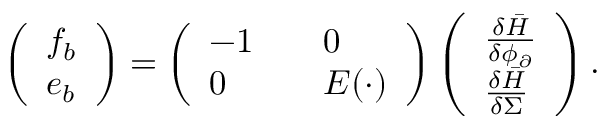<formula> <loc_0><loc_0><loc_500><loc_500>\begin{array} { r } { \left ( \begin{array} { l } { f _ { b } } \\ { e _ { b } } \end{array} \right ) = \left ( \begin{array} { l l } { - 1 \quad } & { 0 } \\ { 0 \quad } & { E ( \cdot ) } \end{array} \right ) \left ( \begin{array} { l } { \frac { \delta \bar { H } } { \delta \phi _ { \partial } } } \\ { \frac { \delta \bar { H } } { \delta \Sigma } } \end{array} \right ) . } \end{array}</formula> 